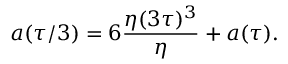Convert formula to latex. <formula><loc_0><loc_0><loc_500><loc_500>a ( \tau / 3 ) = 6 { \frac { \eta ( 3 \tau ) ^ { 3 } } { \eta } } + a ( \tau ) .</formula> 